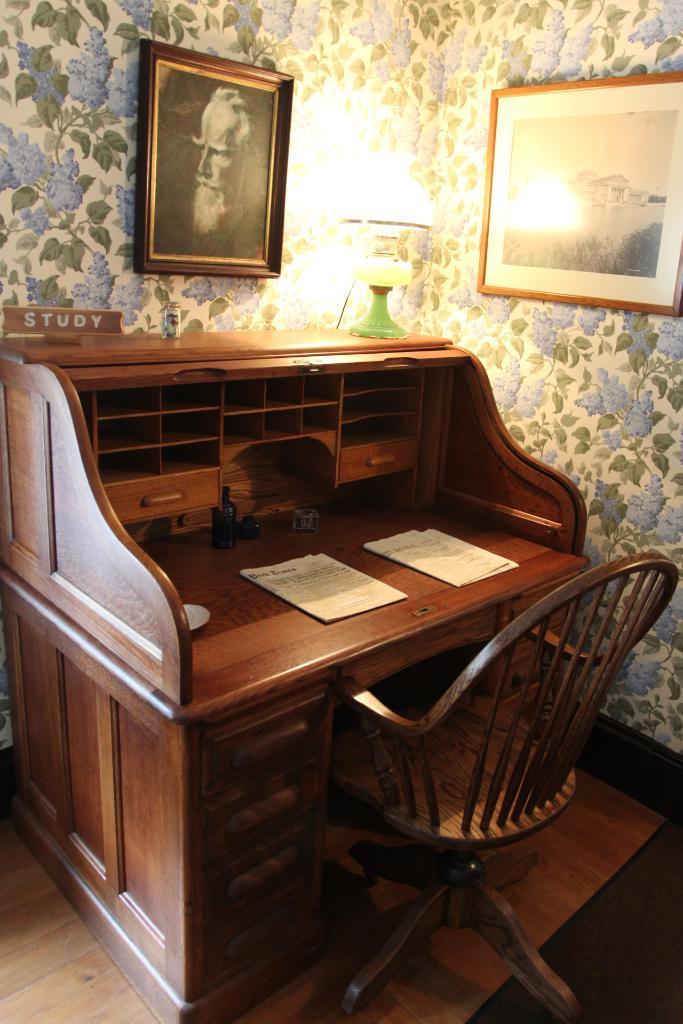In one or two sentences, can you explain what this image depicts? The picture is clicked inside a room. There is a wooden chair and table on the floor and to the top of it there is a label called STUDY. In the background we observe a beautiful decorated wall and a lamp is on the table. 